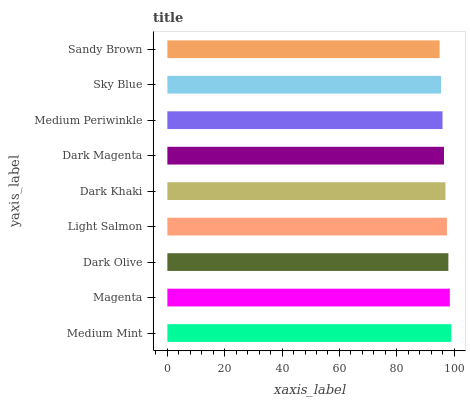Is Sandy Brown the minimum?
Answer yes or no. Yes. Is Medium Mint the maximum?
Answer yes or no. Yes. Is Magenta the minimum?
Answer yes or no. No. Is Magenta the maximum?
Answer yes or no. No. Is Medium Mint greater than Magenta?
Answer yes or no. Yes. Is Magenta less than Medium Mint?
Answer yes or no. Yes. Is Magenta greater than Medium Mint?
Answer yes or no. No. Is Medium Mint less than Magenta?
Answer yes or no. No. Is Dark Khaki the high median?
Answer yes or no. Yes. Is Dark Khaki the low median?
Answer yes or no. Yes. Is Dark Olive the high median?
Answer yes or no. No. Is Dark Olive the low median?
Answer yes or no. No. 